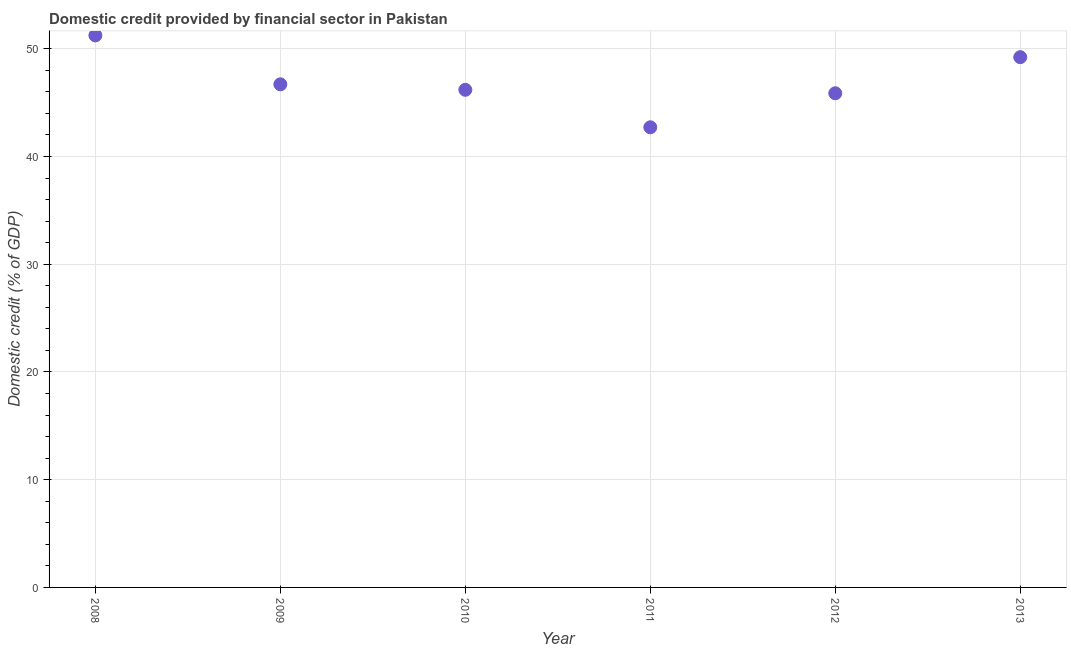What is the domestic credit provided by financial sector in 2011?
Keep it short and to the point. 42.71. Across all years, what is the maximum domestic credit provided by financial sector?
Make the answer very short. 51.23. Across all years, what is the minimum domestic credit provided by financial sector?
Offer a terse response. 42.71. In which year was the domestic credit provided by financial sector minimum?
Provide a succinct answer. 2011. What is the sum of the domestic credit provided by financial sector?
Your response must be concise. 281.91. What is the difference between the domestic credit provided by financial sector in 2012 and 2013?
Give a very brief answer. -3.35. What is the average domestic credit provided by financial sector per year?
Offer a very short reply. 46.98. What is the median domestic credit provided by financial sector?
Provide a succinct answer. 46.44. Do a majority of the years between 2009 and 2012 (inclusive) have domestic credit provided by financial sector greater than 32 %?
Offer a terse response. Yes. What is the ratio of the domestic credit provided by financial sector in 2012 to that in 2013?
Keep it short and to the point. 0.93. Is the difference between the domestic credit provided by financial sector in 2008 and 2010 greater than the difference between any two years?
Give a very brief answer. No. What is the difference between the highest and the second highest domestic credit provided by financial sector?
Offer a terse response. 2.02. Is the sum of the domestic credit provided by financial sector in 2009 and 2012 greater than the maximum domestic credit provided by financial sector across all years?
Offer a terse response. Yes. What is the difference between the highest and the lowest domestic credit provided by financial sector?
Keep it short and to the point. 8.53. Does the domestic credit provided by financial sector monotonically increase over the years?
Make the answer very short. No. How many dotlines are there?
Your answer should be compact. 1. What is the difference between two consecutive major ticks on the Y-axis?
Give a very brief answer. 10. Are the values on the major ticks of Y-axis written in scientific E-notation?
Keep it short and to the point. No. Does the graph contain grids?
Keep it short and to the point. Yes. What is the title of the graph?
Your answer should be very brief. Domestic credit provided by financial sector in Pakistan. What is the label or title of the Y-axis?
Your answer should be very brief. Domestic credit (% of GDP). What is the Domestic credit (% of GDP) in 2008?
Your response must be concise. 51.23. What is the Domestic credit (% of GDP) in 2009?
Make the answer very short. 46.7. What is the Domestic credit (% of GDP) in 2010?
Provide a succinct answer. 46.19. What is the Domestic credit (% of GDP) in 2011?
Keep it short and to the point. 42.71. What is the Domestic credit (% of GDP) in 2012?
Offer a very short reply. 45.86. What is the Domestic credit (% of GDP) in 2013?
Give a very brief answer. 49.22. What is the difference between the Domestic credit (% of GDP) in 2008 and 2009?
Provide a short and direct response. 4.54. What is the difference between the Domestic credit (% of GDP) in 2008 and 2010?
Offer a very short reply. 5.05. What is the difference between the Domestic credit (% of GDP) in 2008 and 2011?
Offer a terse response. 8.53. What is the difference between the Domestic credit (% of GDP) in 2008 and 2012?
Provide a succinct answer. 5.37. What is the difference between the Domestic credit (% of GDP) in 2008 and 2013?
Your answer should be compact. 2.02. What is the difference between the Domestic credit (% of GDP) in 2009 and 2010?
Your answer should be compact. 0.51. What is the difference between the Domestic credit (% of GDP) in 2009 and 2011?
Provide a succinct answer. 3.99. What is the difference between the Domestic credit (% of GDP) in 2009 and 2012?
Provide a succinct answer. 0.83. What is the difference between the Domestic credit (% of GDP) in 2009 and 2013?
Your answer should be compact. -2.52. What is the difference between the Domestic credit (% of GDP) in 2010 and 2011?
Keep it short and to the point. 3.48. What is the difference between the Domestic credit (% of GDP) in 2010 and 2012?
Make the answer very short. 0.32. What is the difference between the Domestic credit (% of GDP) in 2010 and 2013?
Keep it short and to the point. -3.03. What is the difference between the Domestic credit (% of GDP) in 2011 and 2012?
Provide a succinct answer. -3.16. What is the difference between the Domestic credit (% of GDP) in 2011 and 2013?
Provide a short and direct response. -6.51. What is the difference between the Domestic credit (% of GDP) in 2012 and 2013?
Offer a very short reply. -3.35. What is the ratio of the Domestic credit (% of GDP) in 2008 to that in 2009?
Your answer should be compact. 1.1. What is the ratio of the Domestic credit (% of GDP) in 2008 to that in 2010?
Your response must be concise. 1.11. What is the ratio of the Domestic credit (% of GDP) in 2008 to that in 2011?
Your answer should be compact. 1.2. What is the ratio of the Domestic credit (% of GDP) in 2008 to that in 2012?
Offer a terse response. 1.12. What is the ratio of the Domestic credit (% of GDP) in 2008 to that in 2013?
Give a very brief answer. 1.04. What is the ratio of the Domestic credit (% of GDP) in 2009 to that in 2011?
Keep it short and to the point. 1.09. What is the ratio of the Domestic credit (% of GDP) in 2009 to that in 2013?
Provide a succinct answer. 0.95. What is the ratio of the Domestic credit (% of GDP) in 2010 to that in 2011?
Offer a very short reply. 1.08. What is the ratio of the Domestic credit (% of GDP) in 2010 to that in 2012?
Ensure brevity in your answer.  1.01. What is the ratio of the Domestic credit (% of GDP) in 2010 to that in 2013?
Provide a short and direct response. 0.94. What is the ratio of the Domestic credit (% of GDP) in 2011 to that in 2013?
Ensure brevity in your answer.  0.87. What is the ratio of the Domestic credit (% of GDP) in 2012 to that in 2013?
Offer a terse response. 0.93. 